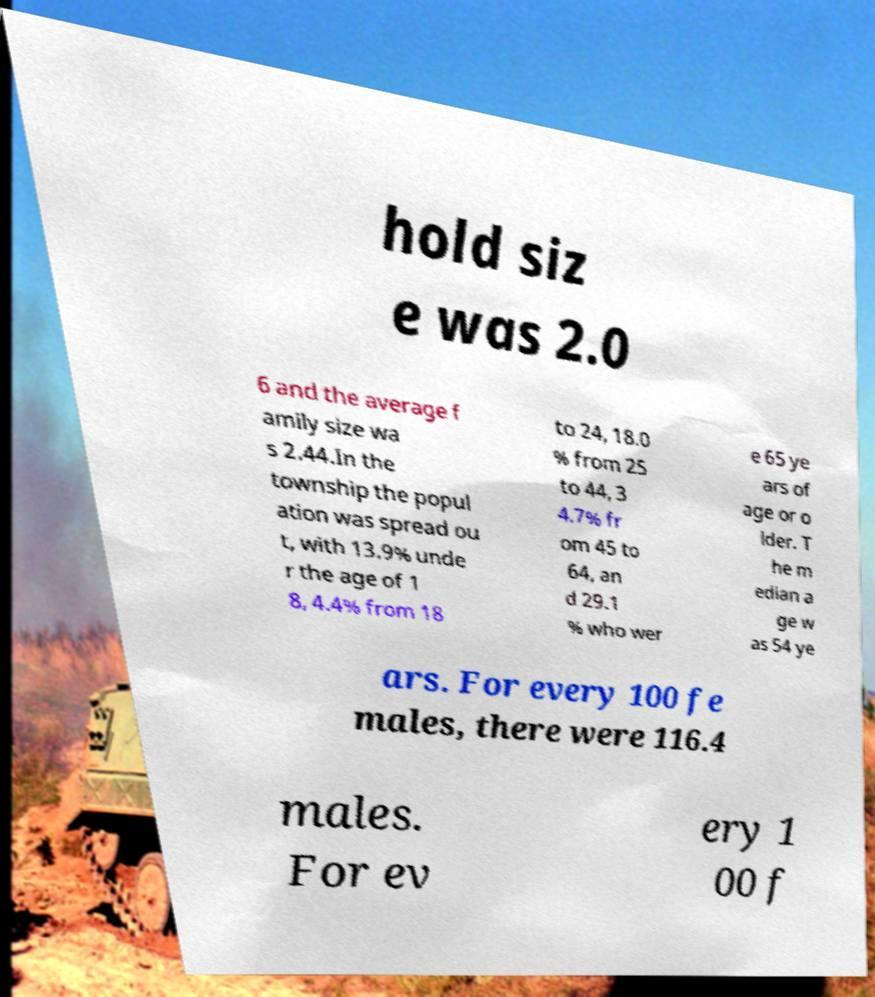There's text embedded in this image that I need extracted. Can you transcribe it verbatim? hold siz e was 2.0 6 and the average f amily size wa s 2.44.In the township the popul ation was spread ou t, with 13.9% unde r the age of 1 8, 4.4% from 18 to 24, 18.0 % from 25 to 44, 3 4.7% fr om 45 to 64, an d 29.1 % who wer e 65 ye ars of age or o lder. T he m edian a ge w as 54 ye ars. For every 100 fe males, there were 116.4 males. For ev ery 1 00 f 